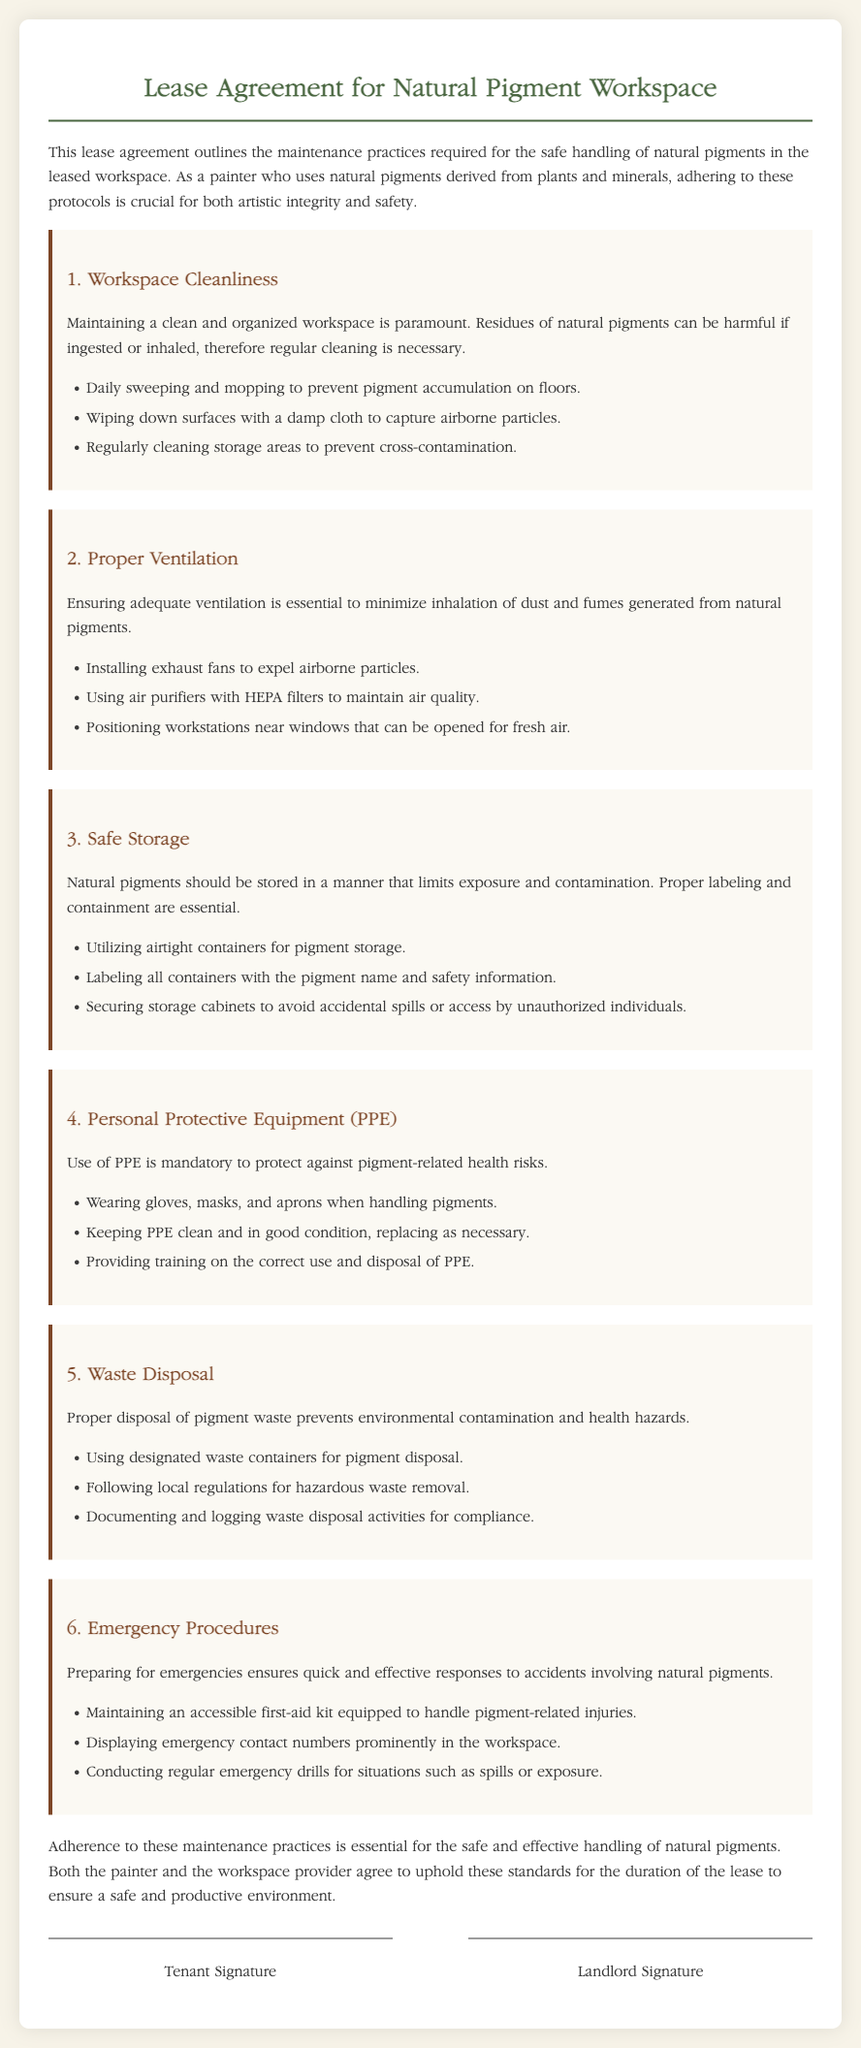What is the main purpose of the lease agreement? The document states that this lease agreement outlines the maintenance practices required for the safe handling of natural pigments in the leased workspace.
Answer: Maintenance practices for safe handling of natural pigments What should be done daily to maintain workspace cleanliness? The document mentions that daily sweeping and mopping to prevent pigment accumulation on floors is necessary.
Answer: Daily sweeping and mopping What type of equipment is recommended for air quality maintenance? The document advises using air purifiers with HEPA filters to maintain air quality.
Answer: Air purifiers with HEPA filters How should natural pigments be stored? The document states that natural pigments should be stored in airtight containers.
Answer: Airtight containers What personal protective equipment is mandatory? The document lists wearing gloves, masks, and aprons when handling pigments as mandatory PPE.
Answer: Gloves, masks, and aprons What is required for emergency procedures? The document specifies that maintaining an accessible first-aid kit equipped to handle pigment-related injuries is required.
Answer: Accessible first-aid kit What should be done with pigment waste? The document instructs using designated waste containers for pigment disposal.
Answer: Designated waste containers Who agrees to uphold the maintenance practices? The document mentions that both the painter and the workspace provider agree to uphold these standards.
Answer: Painter and workspace provider 